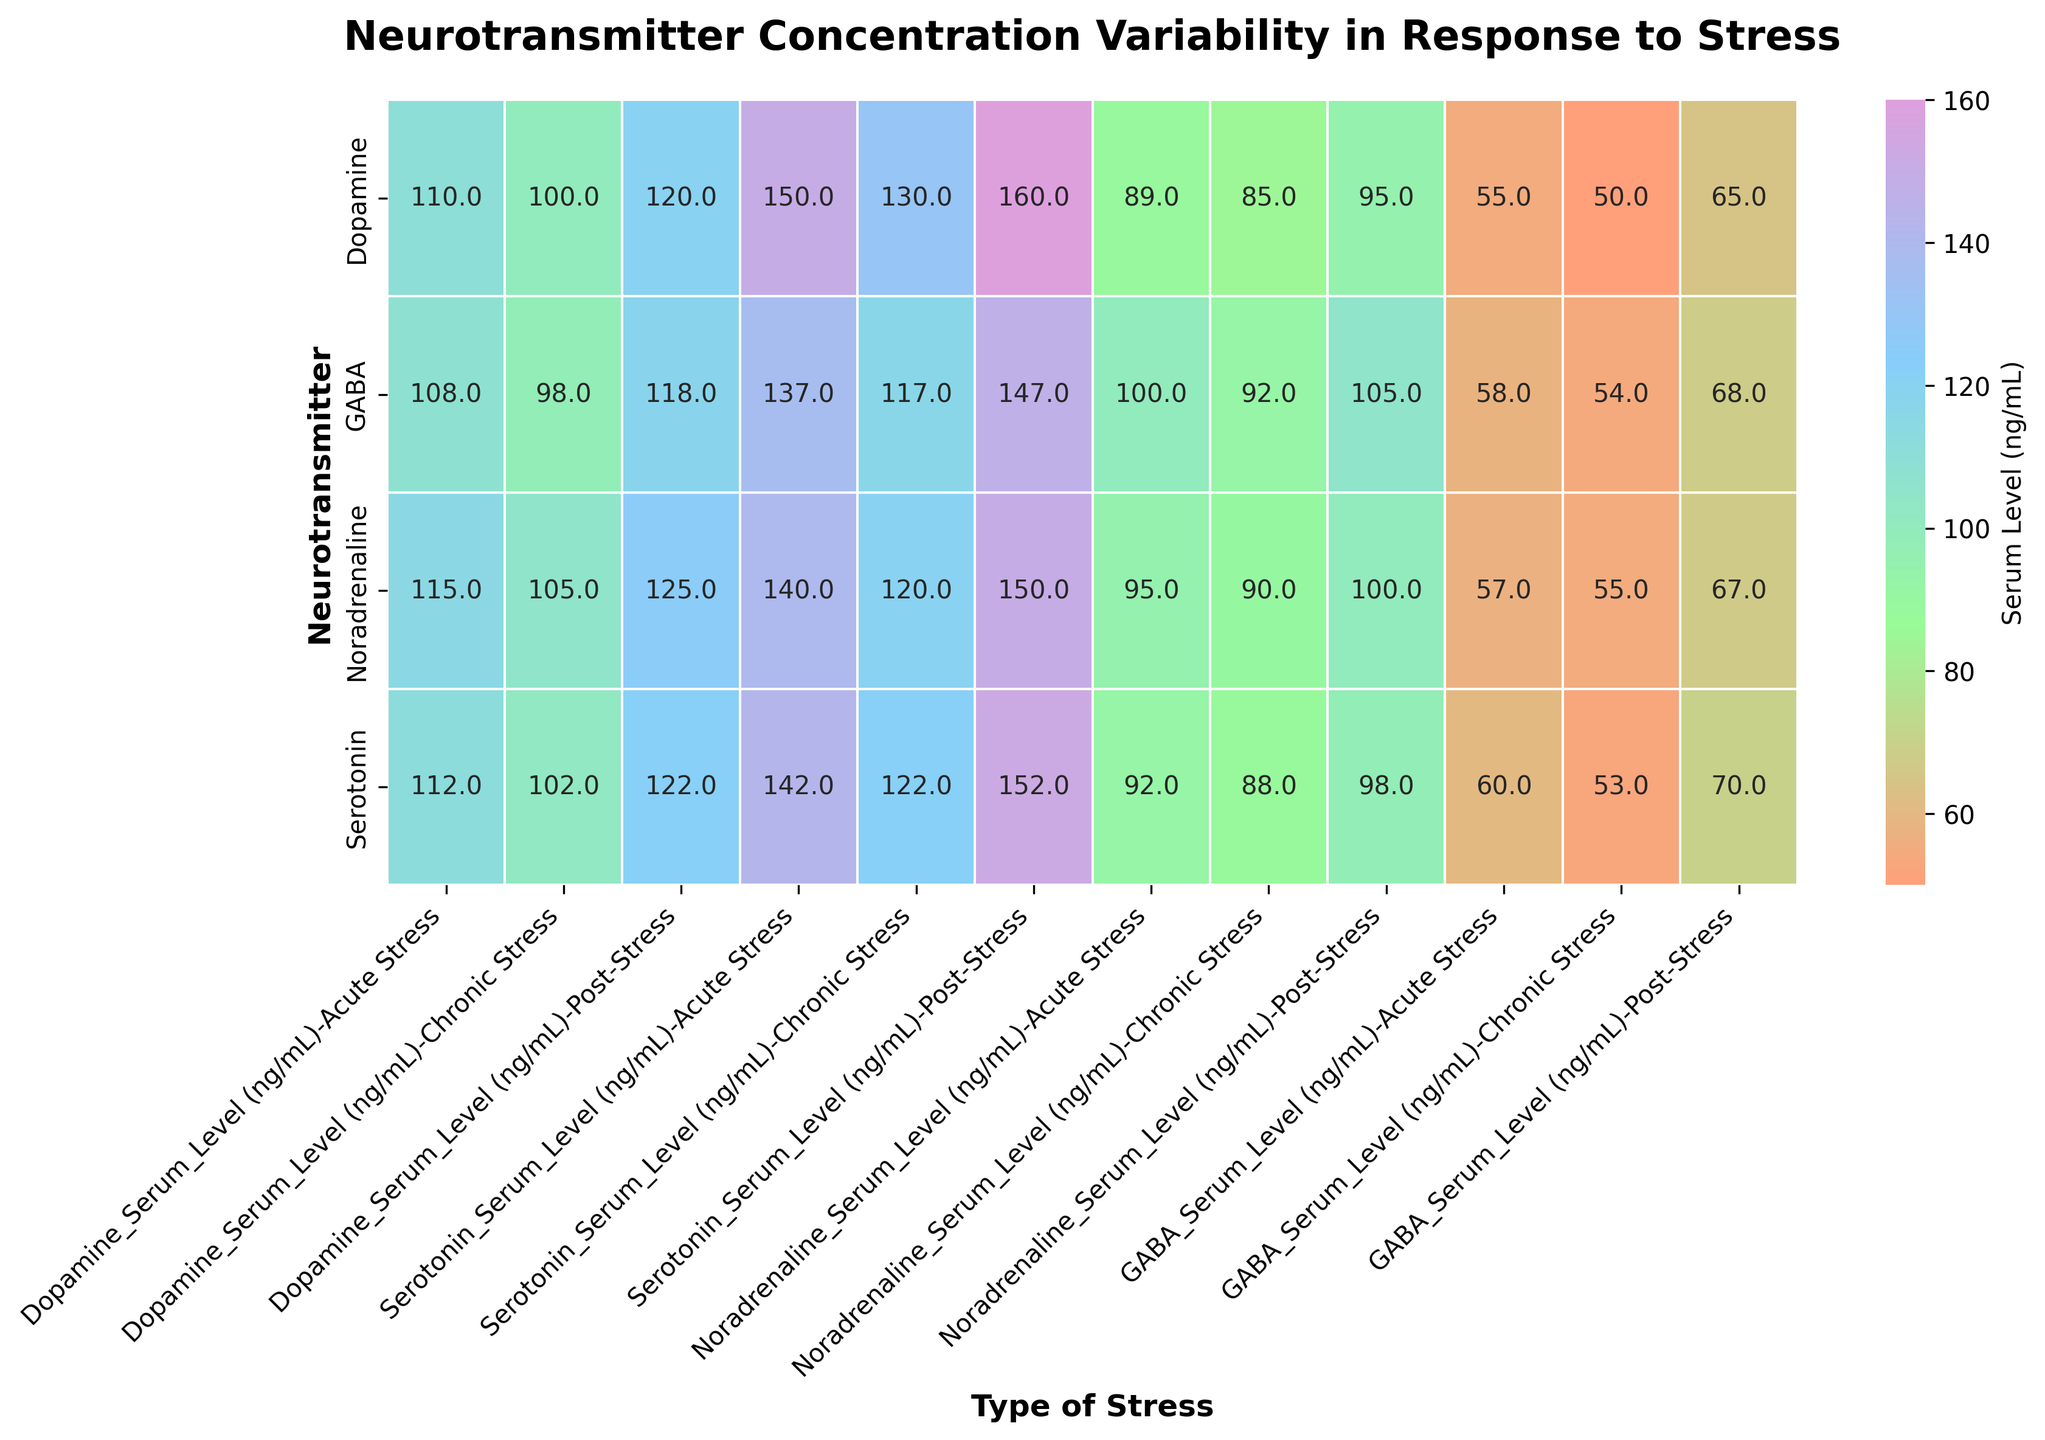What is the title of the heatmap? The title is generally located at the top of the figure, clearly indicating the topic of the visualization. Here, it reads "Neurotransmitter Concentration Variability in Response to Stress."
Answer: Neurotransmitter Concentration Variability in Response to Stress Which neurotransmitter has the highest concentration under Post-Stress conditions? By observing the Post-Stress column and comparing the values for each neurotransmitter, we can see the highest value. Here, 'Noradrenaline' has the highest value of 125 ng/mL.
Answer: Noradrenaline What is the difference in Serotonin levels between Acute Stress and Chronic Stress? Look at the Serotonin levels for Acute Stress (T1) and Chronic Stress (T2) conditions, then subtract the Chronic Stress value from the Acute Stress value: 112 - 102 = 10 ng/mL.
Answer: 10 ng/mL How do GABA levels compare between Acute Stress and Post-Stress conditions? Compare GABA levels in Acute Stress (108 ng/mL) and Post-Stress (118 ng/mL) conditions. 118 ng/mL is greater than 108 ng/mL by 10 ng/mL.
Answer: 10 ng/mL higher in Post-Stress What timepoints are represented in the heatmap? The x-axis (columns) in the heatmap shows the different timepoints measured under various stress conditions: Acute Stress, Chronic Stress, and Post-Stress.
Answer: Acute Stress, Chronic Stress, Post-Stress Which neurotransmitter's level is least affected by Chronic Stress compared to Acute Stress? Compare the changes in levels of all neurotransmitters from Acute Stress to Chronic Stress. GABA shows the smallest change: 108 to 98, a difference of 10 ng/mL.
Answer: GABA Calculate the average Dopamine level across all stress types. Add Dopamine levels across Acute (110), Chronic (100), and Post-Stress (120), then divide by 3: (110+100+120)/3 = 330/3 = 110 ng/mL.
Answer: 110 ng/mL In Acute Stress, which neurotransmitter has the lowest concentration? Within the Acute Stress column, look for the smallest value among all neurotransmitters. GABA has the lowest concentration at 108 ng/mL.
Answer: GABA Which type of stress showed the highest overall neurotransmitter levels? Compare sum of levels for all neurotransmitters across different types of stress. Post-Stress shows the highest overall levels.
Answer: Post-Stress 